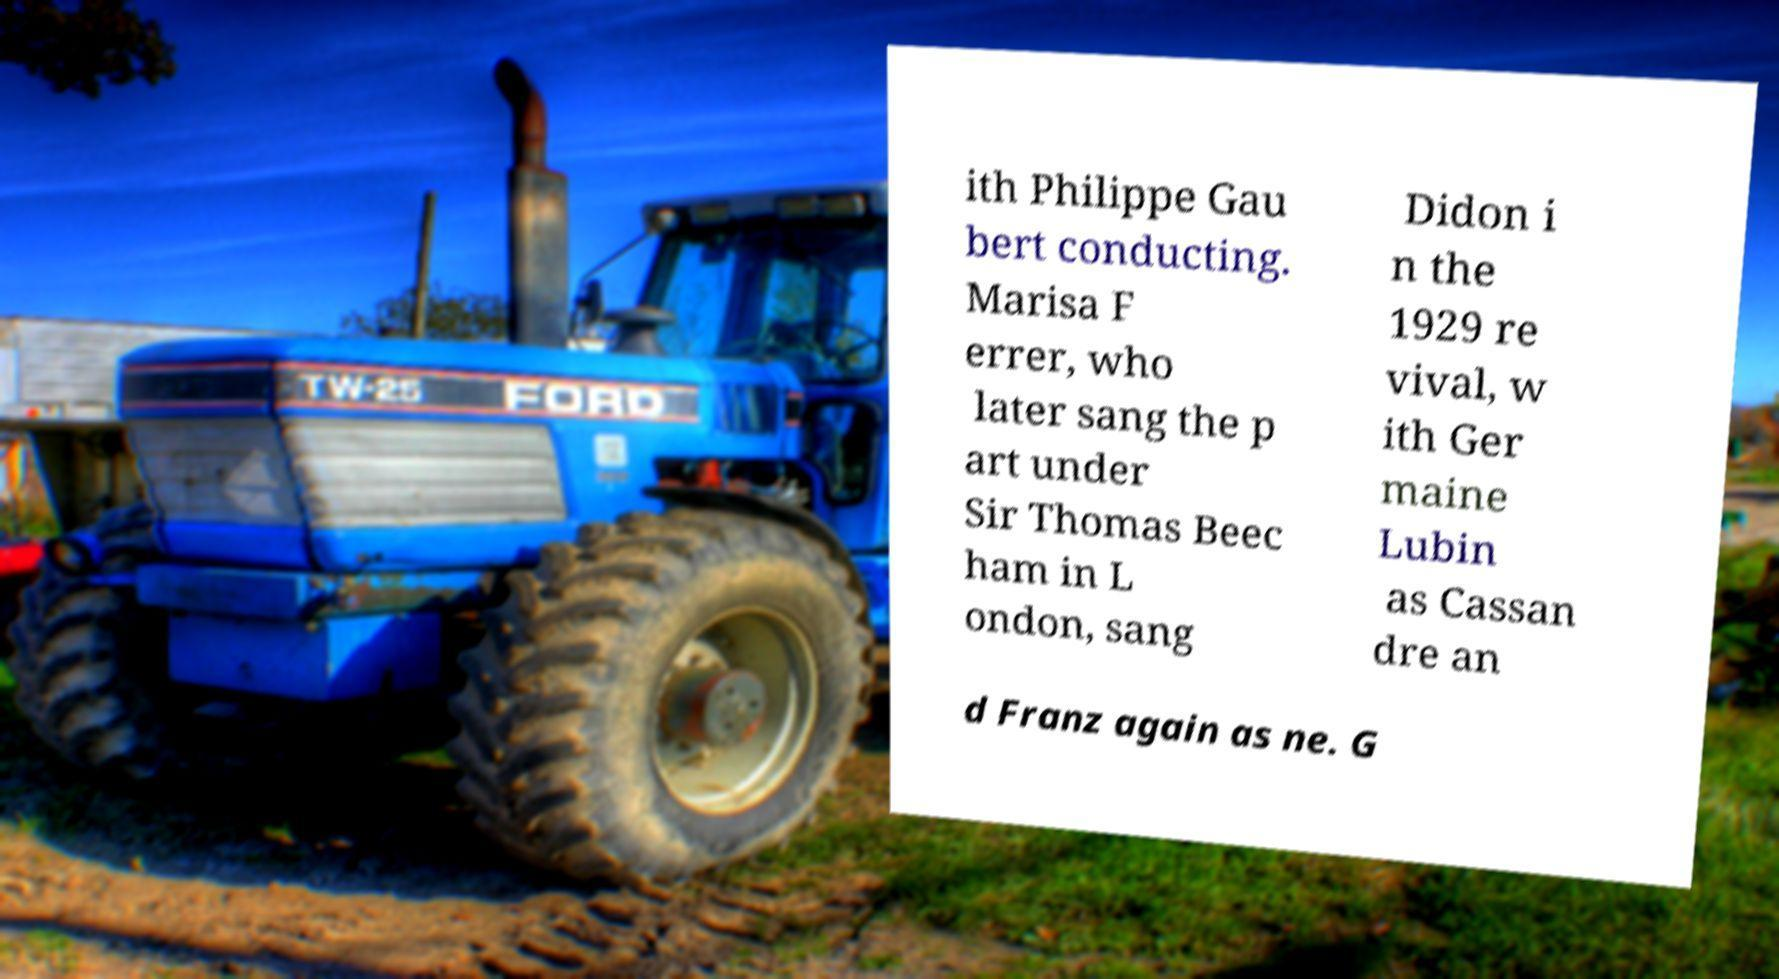For documentation purposes, I need the text within this image transcribed. Could you provide that? ith Philippe Gau bert conducting. Marisa F errer, who later sang the p art under Sir Thomas Beec ham in L ondon, sang Didon i n the 1929 re vival, w ith Ger maine Lubin as Cassan dre an d Franz again as ne. G 